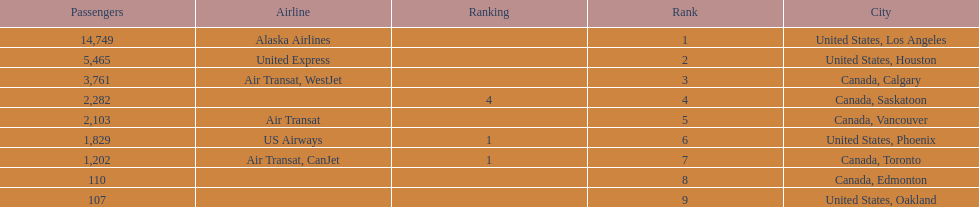Help me parse the entirety of this table. {'header': ['Passengers', 'Airline', 'Ranking', 'Rank', 'City'], 'rows': [['14,749', 'Alaska Airlines', '', '1', 'United States, Los Angeles'], ['5,465', 'United Express', '', '2', 'United States, Houston'], ['3,761', 'Air Transat, WestJet', '', '3', 'Canada, Calgary'], ['2,282', '', '4', '4', 'Canada, Saskatoon'], ['2,103', 'Air Transat', '', '5', 'Canada, Vancouver'], ['1,829', 'US Airways', '1', '6', 'United States, Phoenix'], ['1,202', 'Air Transat, CanJet', '1', '7', 'Canada, Toronto'], ['110', '', '', '8', 'Canada, Edmonton'], ['107', '', '', '9', 'United States, Oakland']]} The difference in passengers between los angeles and toronto 13,547. 